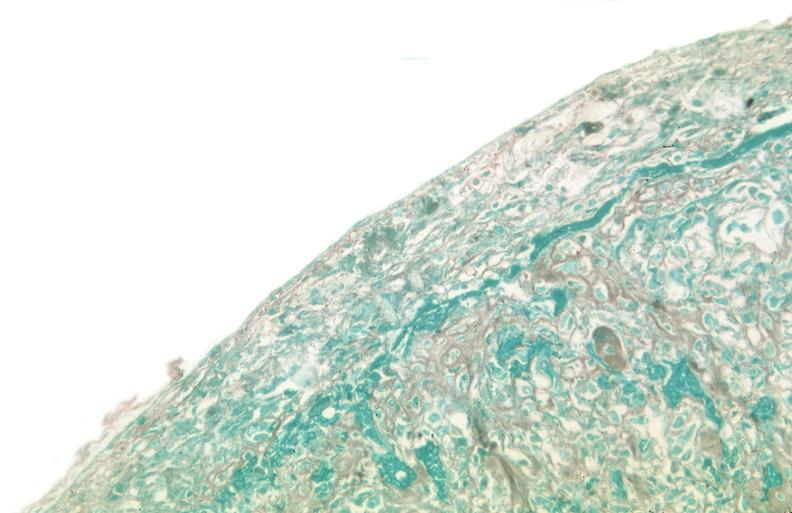what does this image show?
Answer the question using a single word or phrase. Pleura 